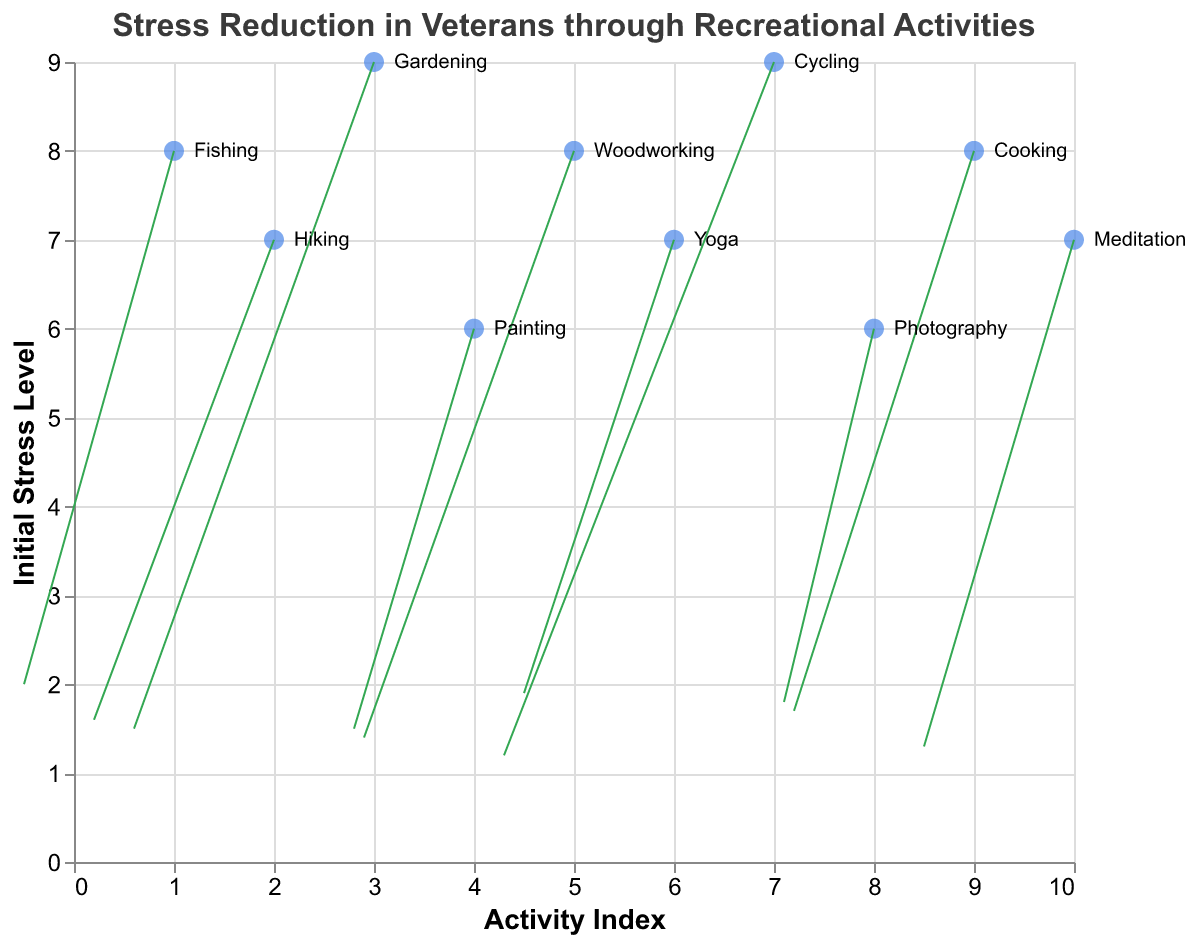How many recreational activities are represented in the plot? To determine the number of unique recreational activities, count the different activities labeled beside each point in the plot. The activities are "Fishing", "Hiking", "Gardening", "Painting", "Woodworking", "Yoga", "Cycling", "Photography", "Cooking", and "Meditation".
Answer: 10 Which recreational activity starts with the highest initial stress level? Look at the highest 'y' value in the graph and identify the corresponding activity label. The highest initial stress level is 9, and it is associated with both "Gardening" and "Cycling".
Answer: Gardening, Cycling What is the stress reduction effect of "Cycling"? Find the initial stress level (y-axis value) for "Cycling" and then look at the vector change in the 'y' direction (v). The initial stress level is 9 and reduction indicated by v is -2.6.
Answer: -2.6 Which activity resulted in the smallest stress reduction? Look at the vector changes (v) and find the smallest negative value. The smallest reduction is -1.4 for "Photography".
Answer: Photography How do the average initial stress levels compare between "Gardening" and "Yoga"? Determine the initial stress levels of both "Gardening" and "Yoga" from the 'y' values. For "Gardening" the value is 9, and for "Yoga" it is 7. Calculate the average by adding both values and dividing by 2. (9 + 7) / 2 = 8
Answer: Gardening: 9, Yoga: 7, Average: 8 Which activity had the largest vector magnitude change in stress level? Calculate the magnitude of the vector for each activity using the formula sqrt(u^2 + v^2). Identify the activity with the largest magnitude. For example, "Cycling" has u = -0.9 and v = -2.6, thus the magnitude is sqrt((-0.9)^2 + (-2.6)^2) ≈ 2.73
Answer: Cycling Which activity starts with the lowest initial stress level and what is it? Find the lowest 'y' value in the graph and identify the corresponding activity label. The lowest initial stress level is 6, and it is associated with "Painting" and "Photography".
Answer: Painting, Photography Was there any activity that had an initial stress level of 8? By looking at the 'y' values, identify activities with an initial stress level of 8. The activities are "Fishing", "Woodworking", and "Cooking".
Answer: Fishing, Woodworking, Cooking What average stress reduction did "Fishing" and "Hiking" achieve? Find the stress reduction (v) for "Fishing" and "Hiking", which are -2 for "Fishing" and -1.8 for "Hiking". Calculate the average by adding both values and dividing by 2. (-2 + -1.8) / 2 = -1.9
Answer: -1.9 